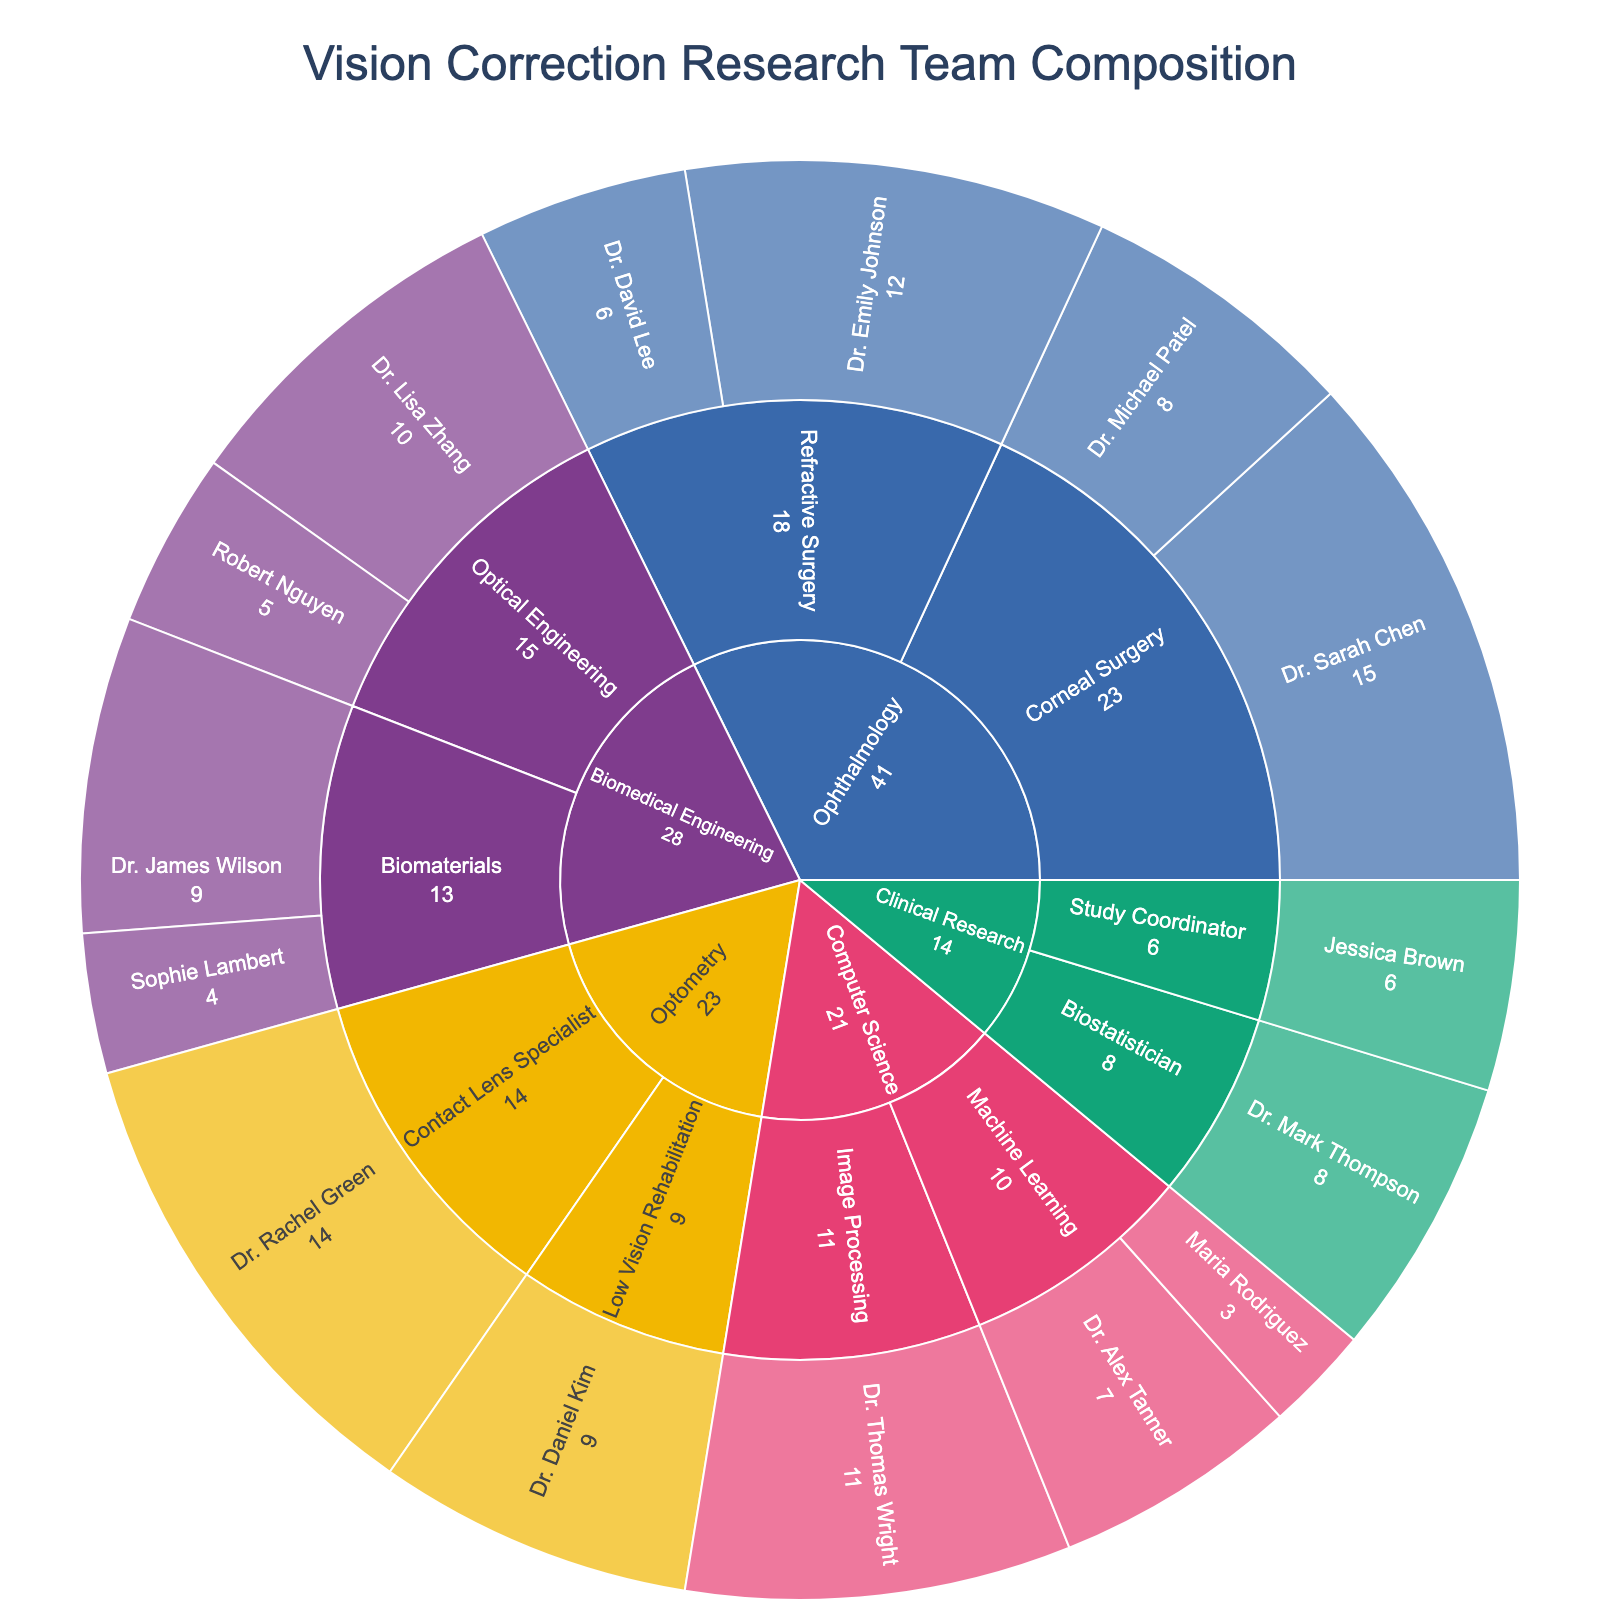What is the title of the sunburst plot? The title is displayed at the top of the sunburst plot. It summarizes the main subject of the visualization.
Answer: Vision Correction Research Team Composition How many people have expertise in 'Machine Learning'? In the 'Computer Science' category, there are two segments labeled with 'Machine Learning', indicating the experts.
Answer: 2 Who has the most years of experience in 'Corneal Surgery'? In the 'Ophthalmology' category under 'Corneal Surgery', compare the years of experience. Dr. Sarah Chen has 15 years, and Dr. Michael Patel has 8 years.
Answer: Dr. Sarah Chen What is the combined years of experience for the 'Biomedical Engineering' team? Summing up the years of experience for all members in the 'Biomedical Engineering' category: 10 (Dr. Lisa Zhang) + 5 (Robert Nguyen) + 9 (Dr. James Wilson) + 4 (Sophie Lambert) = 28
Answer: 28 Who has more experience, Dr. Emily Johnson (Refractive Surgery) or Dr. Thomas Wright (Image Processing)? Compare the experience of Dr. Emily Johnson (12 years) to Dr. Thomas Wright (11 years) by looking at the corresponding segments.
Answer: Dr. Emily Johnson Which expertise under 'Optometry' has more total years of experience? Compare total years under 'Optometry': 'Contact Lens Specialist' (14 years from Dr. Rachel Green) vs. 'Low Vision Rehabilitation' (9 years from Dr. Daniel Kim).
Answer: Contact Lens Specialist Which category has the least total years of experience represented? Sum the years of experience for each category and compare them.
Answer: Computer Science How many experts are there in 'Clinical Research' and what are their roles? Look at the segments under 'Clinical Research' and count them. The roles are 'Study Coordinator' (Jessica Brown) and 'Biostatistician' (Dr. Mark Thompson).
Answer: 2; Study Coordinator and Biostatistician Who has the least years of experience in the team? Identify the individual segment with the smallest value in the figure, which corresponds to Maria Rodriguez with 3 years in 'Machine Learning'.
Answer: Maria Rodriguez What is the color used to represent the 'Ophthalmology' category? Look at the legend or the segments representing 'Ophthalmology' and identify their color.
Answer: Blue 